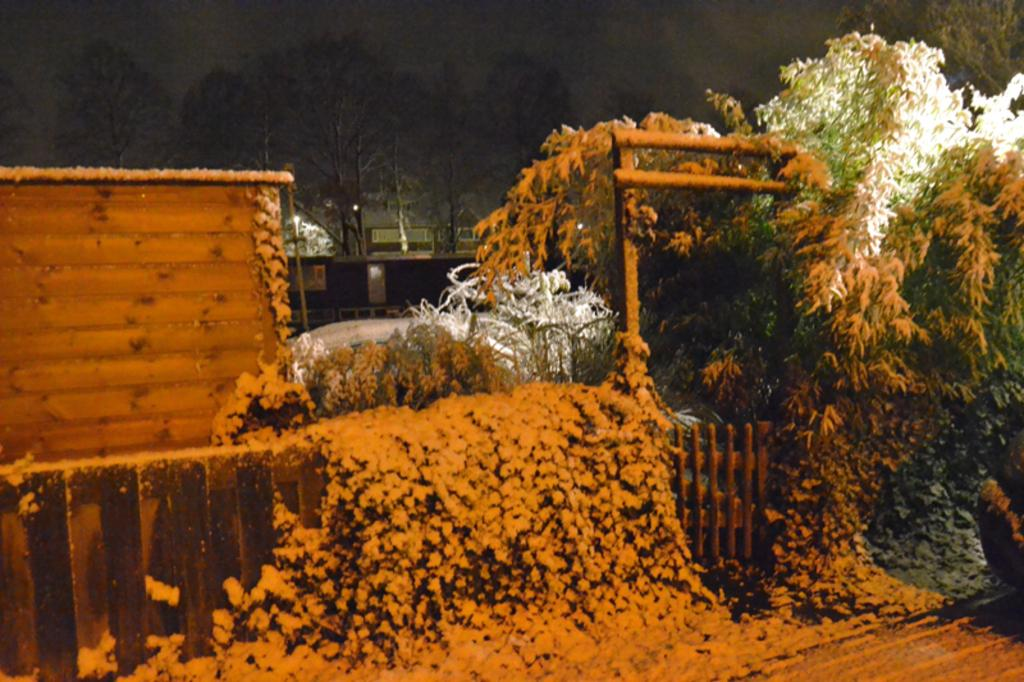What type of vegetation can be seen in the image? There are trees in the image. How is the snow affecting the trees in the image? Some trees are covered with snow. What structure is covered with snow in the image? There is a fence covered with snow. What can be seen in the background of the image? There is a wall and a pole in the background of the image, as well as trees. What type of competition is taking place in the image? There is no competition present in the image; it features trees, snow, and other structures. Can you tell me how many bats are hanging from the trees in the image? There are no bats present in the image; it only features trees, snow, and other structures. 